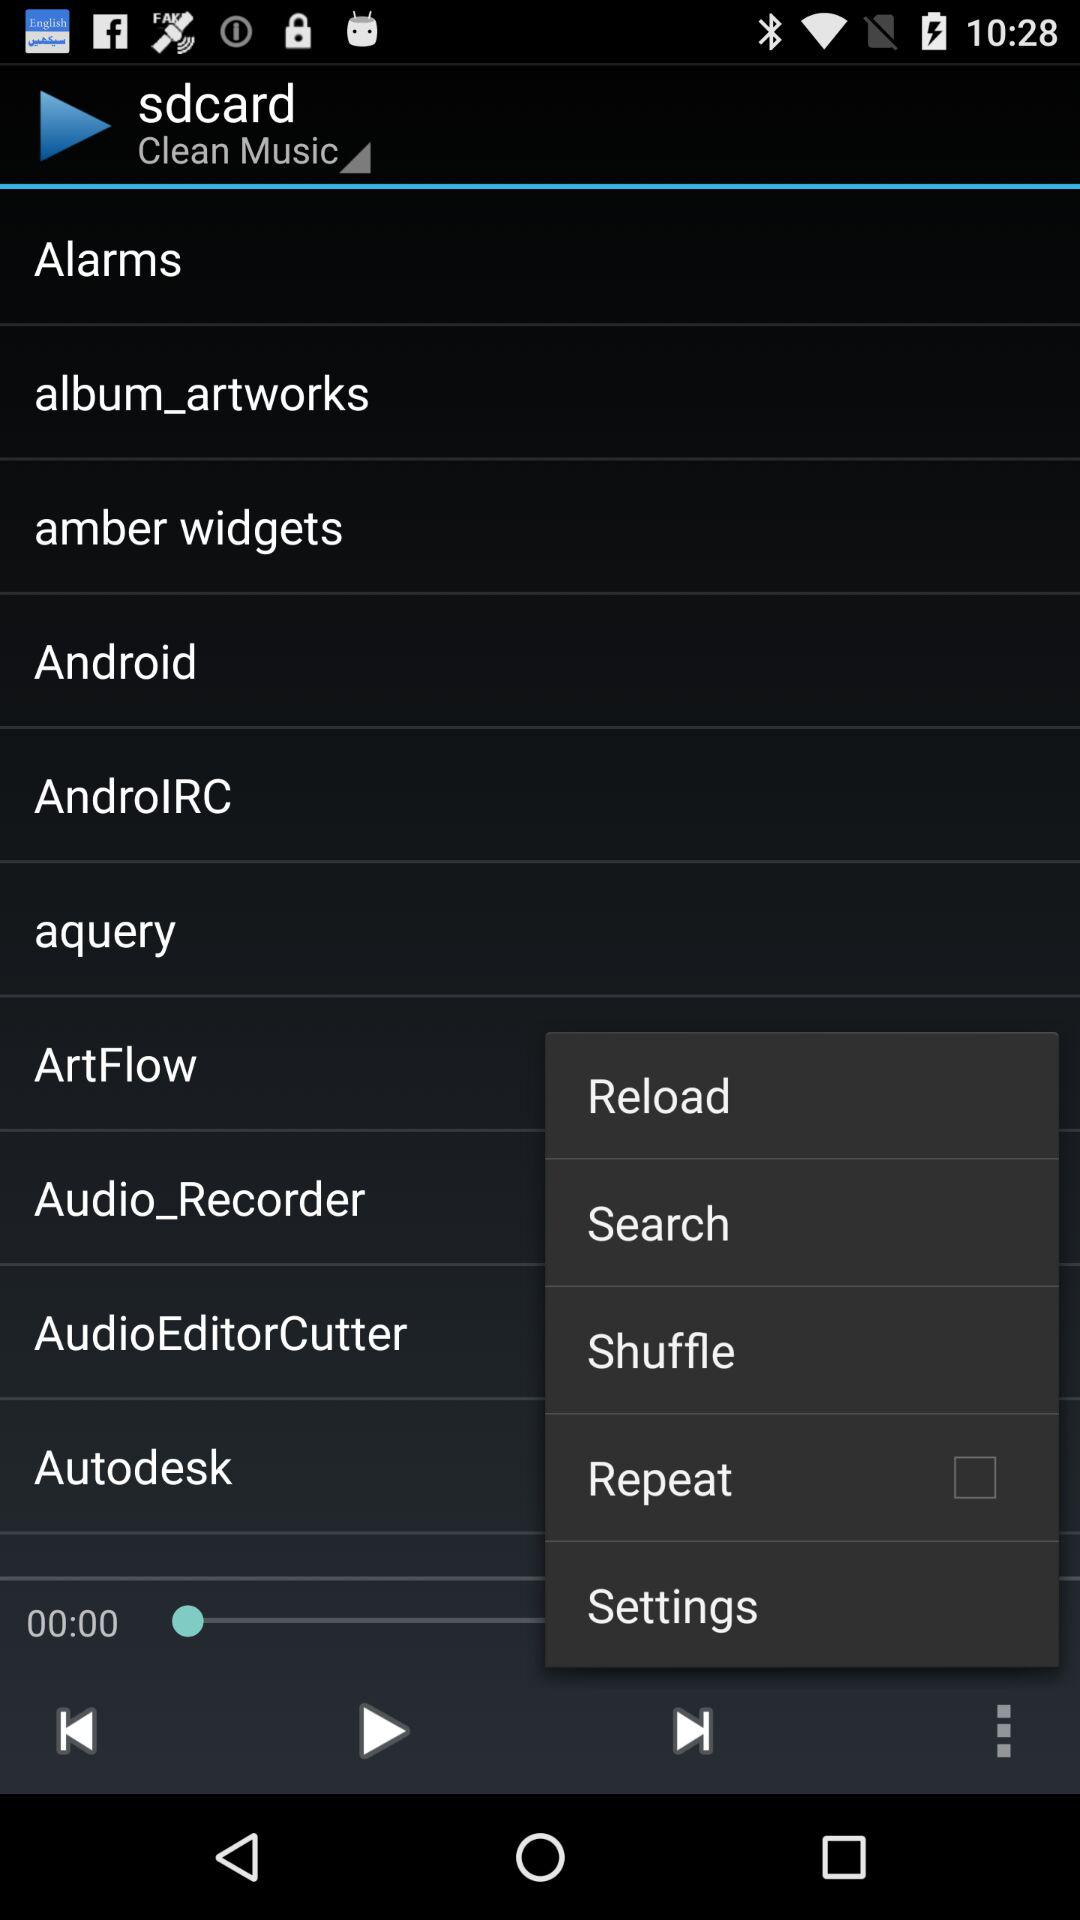What is the status of "Repeat"? The status of "Repeat" is "off". 